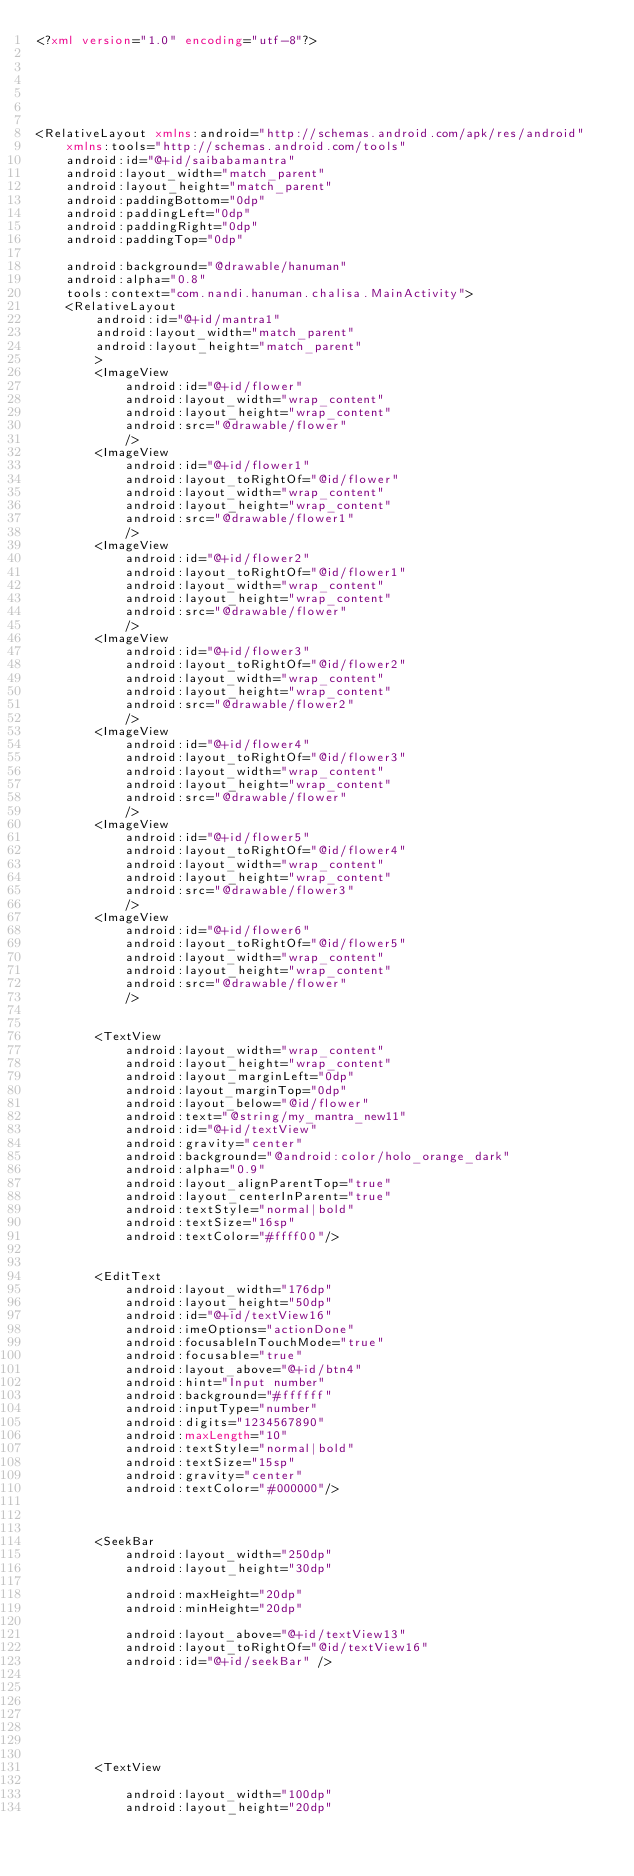Convert code to text. <code><loc_0><loc_0><loc_500><loc_500><_XML_><?xml version="1.0" encoding="utf-8"?>






<RelativeLayout xmlns:android="http://schemas.android.com/apk/res/android"
    xmlns:tools="http://schemas.android.com/tools"
    android:id="@+id/saibabamantra"
    android:layout_width="match_parent"
    android:layout_height="match_parent"
    android:paddingBottom="0dp"
    android:paddingLeft="0dp"
    android:paddingRight="0dp"
    android:paddingTop="0dp"

    android:background="@drawable/hanuman"
    android:alpha="0.8"
    tools:context="com.nandi.hanuman.chalisa.MainActivity">
    <RelativeLayout
        android:id="@+id/mantra1"
        android:layout_width="match_parent"
        android:layout_height="match_parent"
        >
        <ImageView
            android:id="@+id/flower"
            android:layout_width="wrap_content"
            android:layout_height="wrap_content"
            android:src="@drawable/flower"
            />
        <ImageView
            android:id="@+id/flower1"
            android:layout_toRightOf="@id/flower"
            android:layout_width="wrap_content"
            android:layout_height="wrap_content"
            android:src="@drawable/flower1"
            />
        <ImageView
            android:id="@+id/flower2"
            android:layout_toRightOf="@id/flower1"
            android:layout_width="wrap_content"
            android:layout_height="wrap_content"
            android:src="@drawable/flower"
            />
        <ImageView
            android:id="@+id/flower3"
            android:layout_toRightOf="@id/flower2"
            android:layout_width="wrap_content"
            android:layout_height="wrap_content"
            android:src="@drawable/flower2"
            />
        <ImageView
            android:id="@+id/flower4"
            android:layout_toRightOf="@id/flower3"
            android:layout_width="wrap_content"
            android:layout_height="wrap_content"
            android:src="@drawable/flower"
            />
        <ImageView
            android:id="@+id/flower5"
            android:layout_toRightOf="@id/flower4"
            android:layout_width="wrap_content"
            android:layout_height="wrap_content"
            android:src="@drawable/flower3"
            />
        <ImageView
            android:id="@+id/flower6"
            android:layout_toRightOf="@id/flower5"
            android:layout_width="wrap_content"
            android:layout_height="wrap_content"
            android:src="@drawable/flower"
            />


        <TextView
            android:layout_width="wrap_content"
            android:layout_height="wrap_content"
            android:layout_marginLeft="0dp"
            android:layout_marginTop="0dp"
            android:layout_below="@id/flower"
            android:text="@string/my_mantra_new11"
            android:id="@+id/textView"
            android:gravity="center"
            android:background="@android:color/holo_orange_dark"
            android:alpha="0.9"
            android:layout_alignParentTop="true"
            android:layout_centerInParent="true"
            android:textStyle="normal|bold"
            android:textSize="16sp"
            android:textColor="#ffff00"/>


        <EditText
            android:layout_width="176dp"
            android:layout_height="50dp"
            android:id="@+id/textView16"
            android:imeOptions="actionDone"
            android:focusableInTouchMode="true"
            android:focusable="true"
            android:layout_above="@+id/btn4"
            android:hint="Input number"
            android:background="#ffffff"
            android:inputType="number"
            android:digits="1234567890"
            android:maxLength="10"
            android:textStyle="normal|bold"
            android:textSize="15sp"
            android:gravity="center"
            android:textColor="#000000"/>



        <SeekBar
            android:layout_width="250dp"
            android:layout_height="30dp"

            android:maxHeight="20dp"
            android:minHeight="20dp"

            android:layout_above="@+id/textView13"
            android:layout_toRightOf="@id/textView16"
            android:id="@+id/seekBar" />







        <TextView

            android:layout_width="100dp"
            android:layout_height="20dp"
</code> 